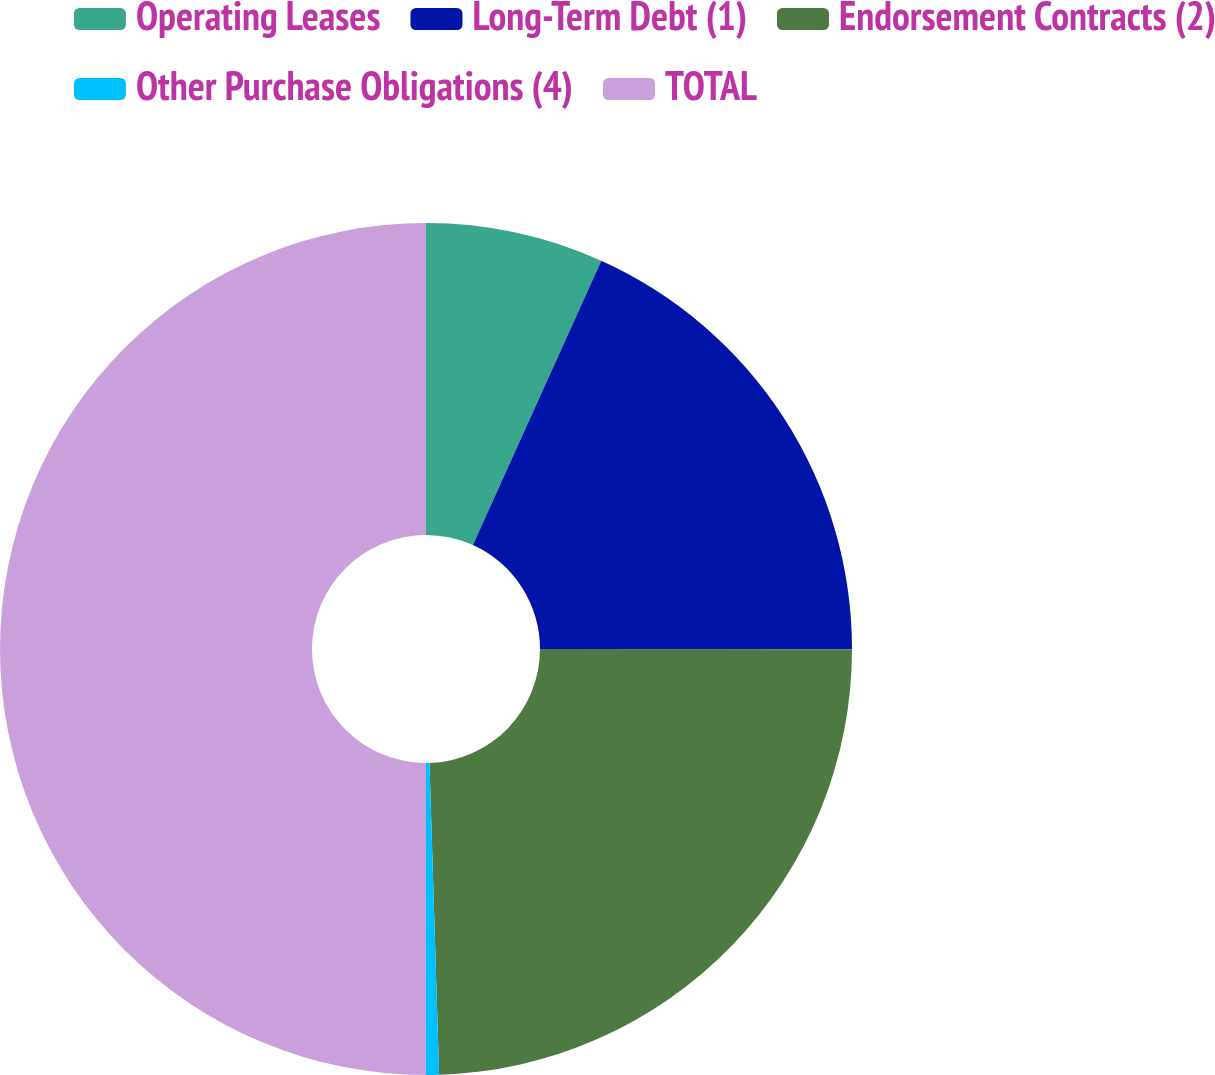<chart> <loc_0><loc_0><loc_500><loc_500><pie_chart><fcel>Operating Leases<fcel>Long-Term Debt (1)<fcel>Endorsement Contracts (2)<fcel>Other Purchase Obligations (4)<fcel>TOTAL<nl><fcel>6.75%<fcel>18.26%<fcel>24.5%<fcel>0.49%<fcel>50.0%<nl></chart> 